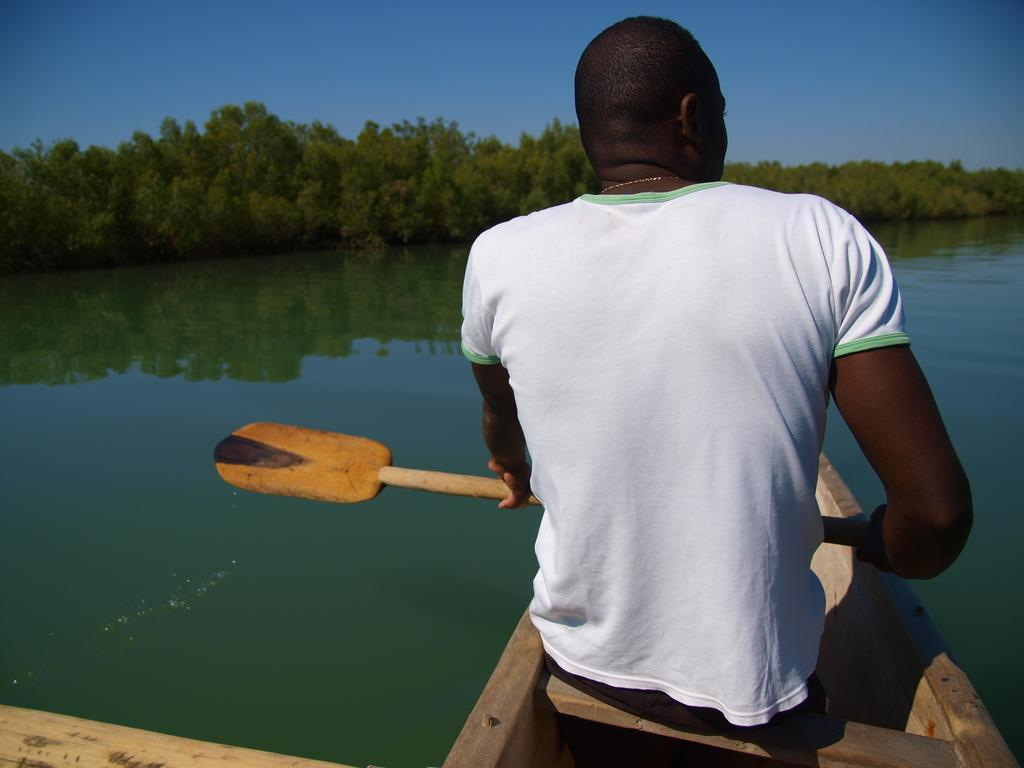What is the person in the image wearing? The person is wearing a white T-shirt. What is the person doing in the image? The person is sitting in a boat and holding a paddle. What is the person's mode of transportation in the image? The person is in a boat. What is visible in the background of the image? There are trees and a blue sky in the background of the image. What is the person's immediate environment in the image? The person is surrounded by water. What type of brake system is installed on the boat in the image? There is no mention of a brake system in the image, as boats typically do not have brakes. 